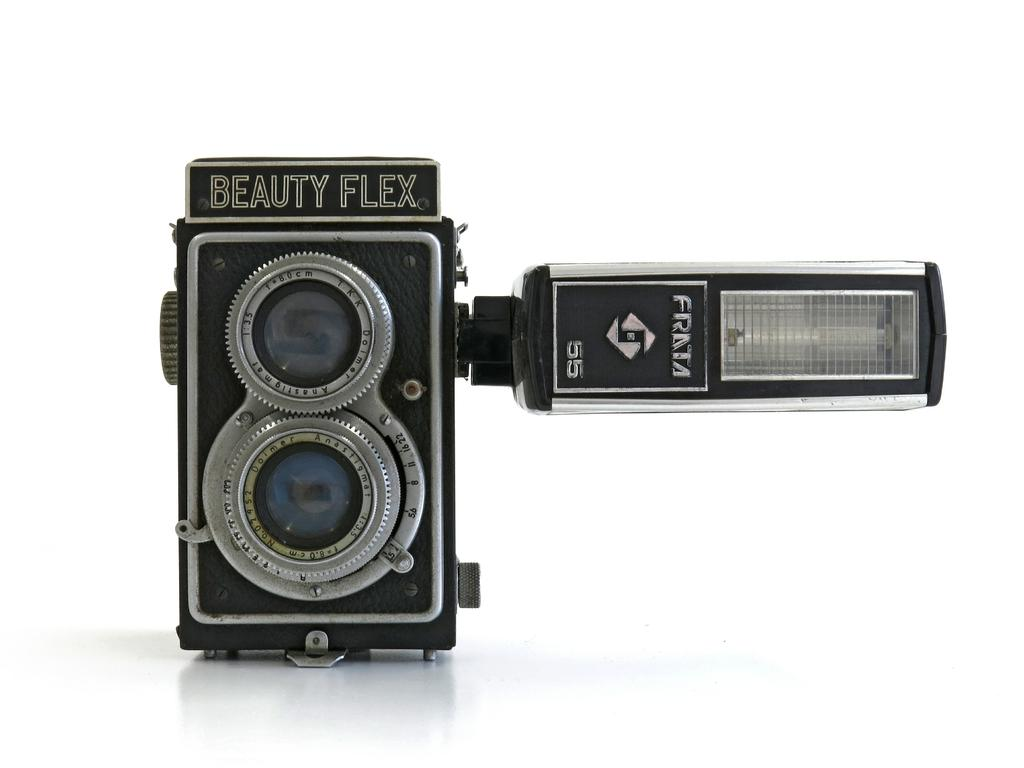Provide a one-sentence caption for the provided image. A Beauty Flex camera with a Franta flash sits alone. 